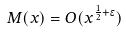<formula> <loc_0><loc_0><loc_500><loc_500>M ( x ) = O ( x ^ { \frac { 1 } { 2 } + \epsilon } )</formula> 